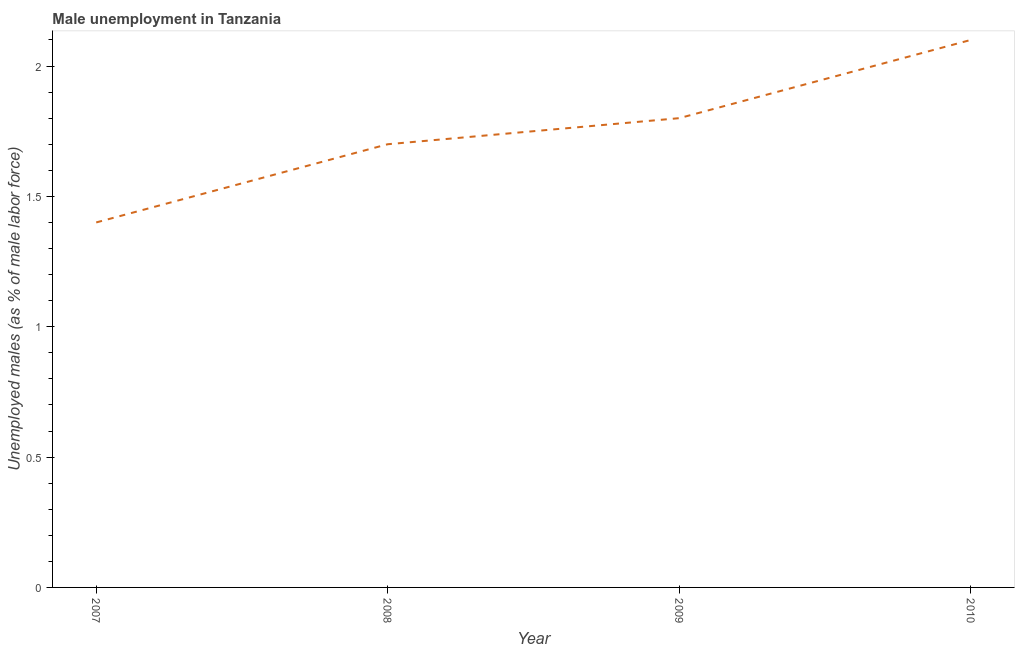What is the unemployed males population in 2007?
Offer a terse response. 1.4. Across all years, what is the maximum unemployed males population?
Offer a very short reply. 2.1. Across all years, what is the minimum unemployed males population?
Your answer should be very brief. 1.4. In which year was the unemployed males population maximum?
Provide a succinct answer. 2010. What is the sum of the unemployed males population?
Offer a very short reply. 7. What is the difference between the unemployed males population in 2007 and 2010?
Your answer should be very brief. -0.7. What is the average unemployed males population per year?
Your answer should be very brief. 1.75. In how many years, is the unemployed males population greater than 0.30000000000000004 %?
Make the answer very short. 4. What is the ratio of the unemployed males population in 2007 to that in 2008?
Keep it short and to the point. 0.82. Is the unemployed males population in 2007 less than that in 2008?
Keep it short and to the point. Yes. Is the difference between the unemployed males population in 2008 and 2010 greater than the difference between any two years?
Your answer should be compact. No. What is the difference between the highest and the second highest unemployed males population?
Provide a short and direct response. 0.3. What is the difference between the highest and the lowest unemployed males population?
Provide a short and direct response. 0.7. In how many years, is the unemployed males population greater than the average unemployed males population taken over all years?
Your response must be concise. 2. Does the unemployed males population monotonically increase over the years?
Provide a succinct answer. Yes. How many years are there in the graph?
Give a very brief answer. 4. What is the difference between two consecutive major ticks on the Y-axis?
Your answer should be compact. 0.5. What is the title of the graph?
Provide a succinct answer. Male unemployment in Tanzania. What is the label or title of the Y-axis?
Your answer should be very brief. Unemployed males (as % of male labor force). What is the Unemployed males (as % of male labor force) in 2007?
Provide a short and direct response. 1.4. What is the Unemployed males (as % of male labor force) of 2008?
Keep it short and to the point. 1.7. What is the Unemployed males (as % of male labor force) of 2009?
Your response must be concise. 1.8. What is the Unemployed males (as % of male labor force) in 2010?
Ensure brevity in your answer.  2.1. What is the difference between the Unemployed males (as % of male labor force) in 2007 and 2008?
Provide a succinct answer. -0.3. What is the difference between the Unemployed males (as % of male labor force) in 2007 and 2010?
Provide a succinct answer. -0.7. What is the difference between the Unemployed males (as % of male labor force) in 2008 and 2009?
Offer a very short reply. -0.1. What is the ratio of the Unemployed males (as % of male labor force) in 2007 to that in 2008?
Your response must be concise. 0.82. What is the ratio of the Unemployed males (as % of male labor force) in 2007 to that in 2009?
Provide a short and direct response. 0.78. What is the ratio of the Unemployed males (as % of male labor force) in 2007 to that in 2010?
Your answer should be very brief. 0.67. What is the ratio of the Unemployed males (as % of male labor force) in 2008 to that in 2009?
Keep it short and to the point. 0.94. What is the ratio of the Unemployed males (as % of male labor force) in 2008 to that in 2010?
Offer a terse response. 0.81. What is the ratio of the Unemployed males (as % of male labor force) in 2009 to that in 2010?
Your response must be concise. 0.86. 